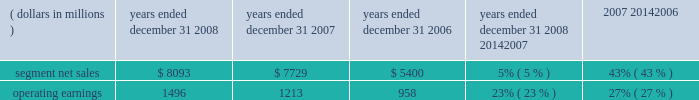The segment had operating earnings of $ 709 million in 2007 , compared to operating earnings of $ 787 million in 2006 .
The decrease in operating earnings was primarily due to a decrease in gross margin , driven by : ( i ) lower net sales of iden infrastructure equipment , and ( ii ) continued competitive pricing pressure in the market for gsm infrastructure equipment , partially offset by : ( i ) increased net sales of digital entertainment devices , and ( ii ) the reversal of reorganization of business accruals recorded in 2006 relating to employee severance which were no longer needed .
Sg&a expenses increased primarily due to the expenses from recently acquired businesses , partially offset by savings from cost-reduction initiatives .
R&d expenditures decreased primarily due to savings from cost- reduction initiatives , partially offset by expenditures by recently acquired businesses and continued investment in digital entertainment devices and wimax .
As a percentage of net sales in 2007 as compared to 2006 , gross margin , sg&a expenses , r&d expenditures and operating margin all decreased .
In 2007 , sales to the segment 2019s top five customers represented approximately 43% ( 43 % ) of the segment 2019s net sales .
The segment 2019s backlog was $ 2.6 billion at december 31 , 2007 , compared to $ 3.2 billion at december 31 , 2006 .
In the home business , demand for the segment 2019s products depends primarily on the level of capital spending by broadband operators for constructing , rebuilding or upgrading their communications systems , and for offering advanced services .
During the second quarter of 2007 , the segment began shipping digital set-tops that support the federal communications commission ( 201cfcc 201d ) 2014 mandated separable security requirement .
Fcc regulations mandating the separation of security functionality from set-tops went into effect on july 1 , 2007 .
As a result of these regulations , many cable service providers accelerated their purchases of set-tops in the first half of 2007 .
Additionally , in 2007 , our digital video customers significantly increased their purchases of the segment 2019s products and services , primarily due to increased demand for digital entertainment devices , particularly hd/dvr devices .
During 2007 , the segment completed the acquisitions of : ( i ) netopia , inc. , a broadband equipment provider for dsl customers , which allows for phone , tv and fast internet connections , ( ii ) tut systems , inc. , a leading developer of edge routing and video encoders , ( iii ) modulus video , inc. , a provider of mpeg-4 advanced coding compression systems designed for delivery of high-value video content in ip set-top devices for the digital video , broadcast and satellite marketplaces , ( iv ) terayon communication systems , inc. , a provider of real-time digital video networking applications to cable , satellite and telecommunication service providers worldwide , and ( v ) leapstone systems , inc. , a provider of intelligent multimedia service delivery and content management applications to networks operators .
These acquisitions enhance our ability to provide complete end-to-end systems for the delivery of advanced video , voice and data services .
In december 2007 , motorola completed the sale of ecc to emerson for $ 346 million in cash .
Enterprise mobility solutions segment the enterprise mobility solutions segment designs , manufactures , sells , installs and services analog and digital two-way radio , voice and data communications products and systems for private networks , wireless broadband systems and end-to-end enterprise mobility solutions to a wide range of enterprise markets , including government and public safety agencies ( which , together with all sales to distributors of two-way communication products , are referred to as the 201cgovernment and public safety market 201d ) , as well as retail , energy and utilities , transportation , manufacturing , healthcare and other commercial customers ( which , collectively , are referred to as the 201ccommercial enterprise market 201d ) .
In 2008 , the segment 2019s net sales represented 27% ( 27 % ) of the company 2019s consolidated net sales , compared to 21% ( 21 % ) in 2007 and 13% ( 13 % ) in 2006 .
( dollars in millions ) 2008 2007 2006 2008 20142007 2007 20142006 years ended december 31 percent change .
Segment results 20142008 compared to 2007 in 2008 , the segment 2019s net sales increased 5% ( 5 % ) to $ 8.1 billion , compared to $ 7.7 billion in 2007 .
The 5% ( 5 % ) increase in net sales reflects an 8% ( 8 % ) increase in net sales to the government and public safety market , partially offset by a 2% ( 2 % ) decrease in net sales to the commercial enterprise market .
The increase in net sales to the government and public safety market was primarily driven by : ( i ) increased net sales outside of north america , and ( ii ) the net sales generated by vertex standard co. , ltd. , a business the company acquired a controlling interest of in january 2008 , partially offset by lower net sales in north america .
On a geographic basis , the segment 2019s net sales were higher in emea , asia and latin america and lower in north america .
65management 2019s discussion and analysis of financial condition and results of operations %%transmsg*** transmitting job : c49054 pcn : 068000000 ***%%pcmsg|65 |00024|yes|no|02/24/2009 12:31|0|0|page is valid , no graphics -- color : n| .
What was the efficiently , in a percent , of converting segmented sales to operating earnings for 2006? 
Rationale: to figure out the conversion of segmented sales to operating earnings one must take the operating earnings and divide it by the segmented net sales .
Computations: (958 / 5400)
Answer: 0.17741. 